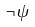<formula> <loc_0><loc_0><loc_500><loc_500>\neg \psi</formula> 